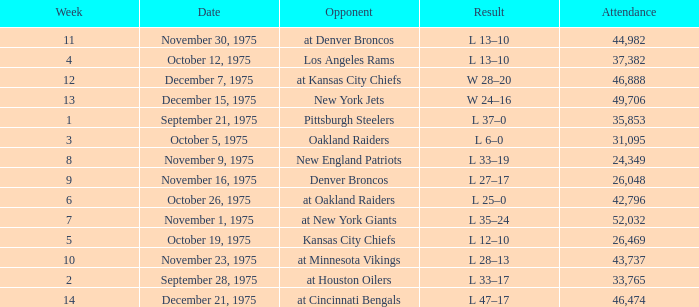What is the lowest Week when the result was l 6–0? 3.0. 